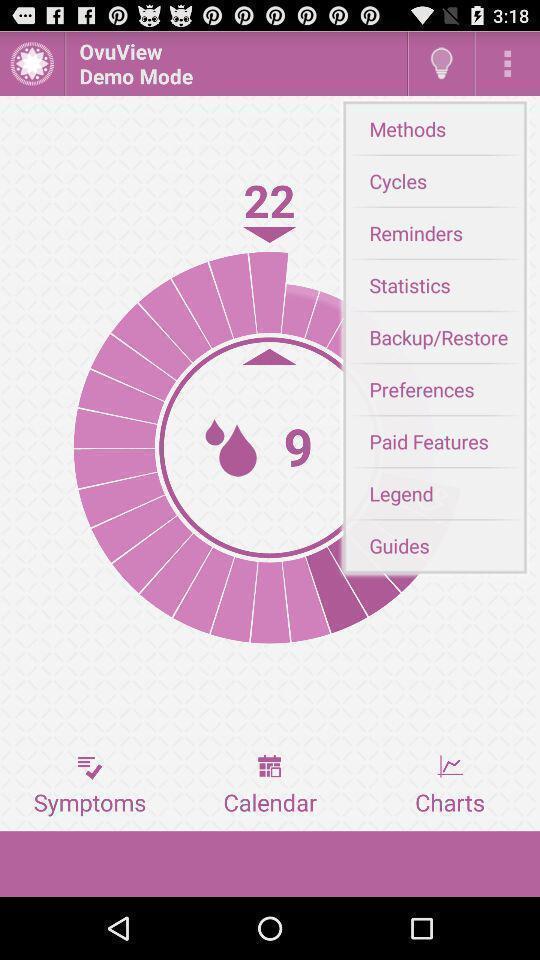What is the overall content of this screenshot? Tracking page of a period and fertility app. 